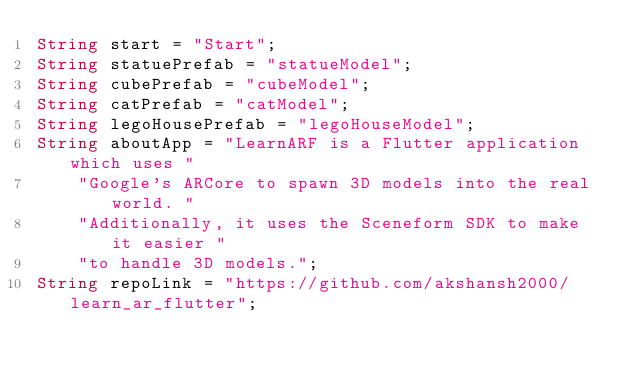<code> <loc_0><loc_0><loc_500><loc_500><_Dart_>String start = "Start";
String statuePrefab = "statueModel";
String cubePrefab = "cubeModel";
String catPrefab = "catModel";
String legoHousePrefab = "legoHouseModel";
String aboutApp = "LearnARF is a Flutter application which uses "
    "Google's ARCore to spawn 3D models into the real world. "
    "Additionally, it uses the Sceneform SDK to make it easier "
    "to handle 3D models.";
String repoLink = "https://github.com/akshansh2000/learn_ar_flutter";
</code> 